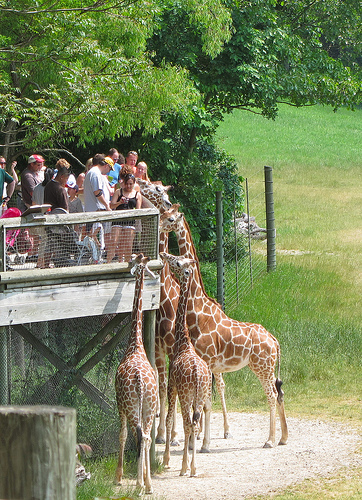Can you tell me more about giraffes' habitat preferences? Giraffes are indigenous to Africa and prefer a habitat where they have access to scattered trees and shrubs, which are essential for their feeding. They thrive in dry savannas and open woodlands. The enclosure in the image is designed to mimic such an environment to keep the giraffes comfortable and healthy. 